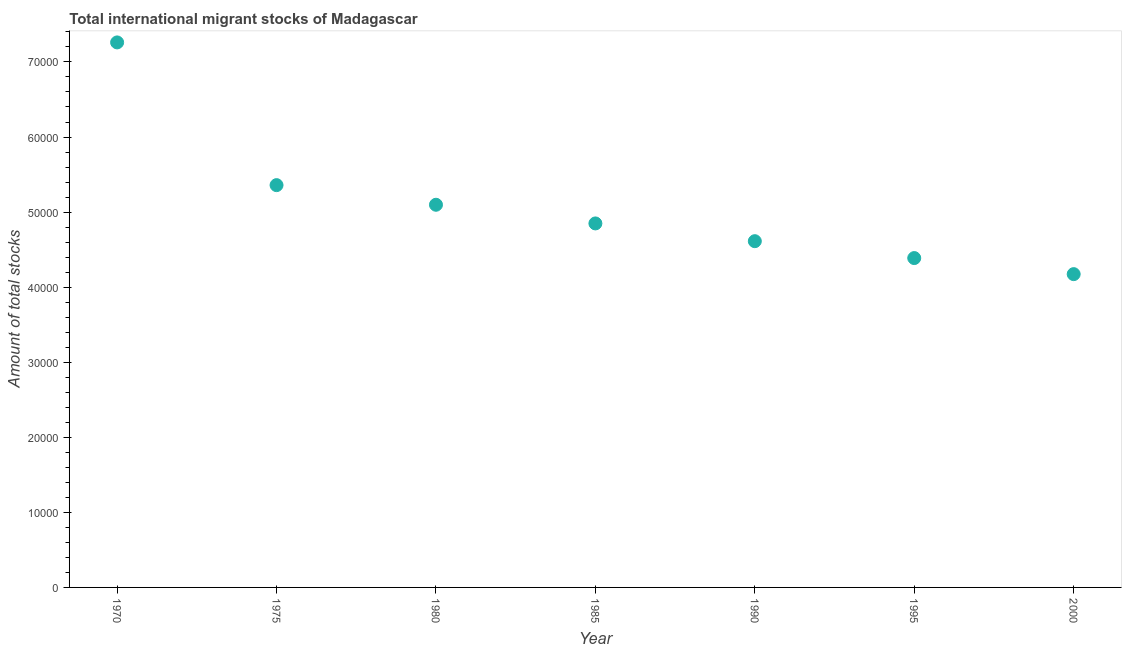What is the total number of international migrant stock in 1985?
Give a very brief answer. 4.85e+04. Across all years, what is the maximum total number of international migrant stock?
Your answer should be compact. 7.26e+04. Across all years, what is the minimum total number of international migrant stock?
Offer a terse response. 4.17e+04. What is the sum of the total number of international migrant stock?
Ensure brevity in your answer.  3.57e+05. What is the difference between the total number of international migrant stock in 1990 and 1995?
Offer a very short reply. 2250. What is the average total number of international migrant stock per year?
Provide a succinct answer. 5.11e+04. What is the median total number of international migrant stock?
Your answer should be compact. 4.85e+04. What is the ratio of the total number of international migrant stock in 1975 to that in 1995?
Keep it short and to the point. 1.22. Is the total number of international migrant stock in 1985 less than that in 2000?
Provide a short and direct response. No. Is the difference between the total number of international migrant stock in 1990 and 1995 greater than the difference between any two years?
Your response must be concise. No. What is the difference between the highest and the second highest total number of international migrant stock?
Give a very brief answer. 1.90e+04. Is the sum of the total number of international migrant stock in 1980 and 2000 greater than the maximum total number of international migrant stock across all years?
Your answer should be compact. Yes. What is the difference between the highest and the lowest total number of international migrant stock?
Offer a terse response. 3.09e+04. In how many years, is the total number of international migrant stock greater than the average total number of international migrant stock taken over all years?
Your response must be concise. 2. Does the total number of international migrant stock monotonically increase over the years?
Offer a very short reply. No. How many dotlines are there?
Give a very brief answer. 1. Does the graph contain grids?
Offer a terse response. No. What is the title of the graph?
Offer a very short reply. Total international migrant stocks of Madagascar. What is the label or title of the X-axis?
Make the answer very short. Year. What is the label or title of the Y-axis?
Your answer should be compact. Amount of total stocks. What is the Amount of total stocks in 1970?
Your response must be concise. 7.26e+04. What is the Amount of total stocks in 1975?
Provide a succinct answer. 5.36e+04. What is the Amount of total stocks in 1980?
Ensure brevity in your answer.  5.10e+04. What is the Amount of total stocks in 1985?
Give a very brief answer. 4.85e+04. What is the Amount of total stocks in 1990?
Offer a very short reply. 4.61e+04. What is the Amount of total stocks in 1995?
Your answer should be compact. 4.39e+04. What is the Amount of total stocks in 2000?
Offer a very short reply. 4.17e+04. What is the difference between the Amount of total stocks in 1970 and 1975?
Provide a short and direct response. 1.90e+04. What is the difference between the Amount of total stocks in 1970 and 1980?
Offer a very short reply. 2.16e+04. What is the difference between the Amount of total stocks in 1970 and 1985?
Your response must be concise. 2.41e+04. What is the difference between the Amount of total stocks in 1970 and 1990?
Your response must be concise. 2.65e+04. What is the difference between the Amount of total stocks in 1970 and 1995?
Provide a short and direct response. 2.87e+04. What is the difference between the Amount of total stocks in 1970 and 2000?
Your answer should be very brief. 3.09e+04. What is the difference between the Amount of total stocks in 1975 and 1980?
Offer a terse response. 2614. What is the difference between the Amount of total stocks in 1975 and 1985?
Your response must be concise. 5101. What is the difference between the Amount of total stocks in 1975 and 1990?
Make the answer very short. 7466. What is the difference between the Amount of total stocks in 1975 and 1995?
Keep it short and to the point. 9716. What is the difference between the Amount of total stocks in 1975 and 2000?
Offer a very short reply. 1.19e+04. What is the difference between the Amount of total stocks in 1980 and 1985?
Ensure brevity in your answer.  2487. What is the difference between the Amount of total stocks in 1980 and 1990?
Your response must be concise. 4852. What is the difference between the Amount of total stocks in 1980 and 1995?
Provide a succinct answer. 7102. What is the difference between the Amount of total stocks in 1980 and 2000?
Keep it short and to the point. 9242. What is the difference between the Amount of total stocks in 1985 and 1990?
Offer a very short reply. 2365. What is the difference between the Amount of total stocks in 1985 and 1995?
Give a very brief answer. 4615. What is the difference between the Amount of total stocks in 1985 and 2000?
Your answer should be very brief. 6755. What is the difference between the Amount of total stocks in 1990 and 1995?
Provide a short and direct response. 2250. What is the difference between the Amount of total stocks in 1990 and 2000?
Your response must be concise. 4390. What is the difference between the Amount of total stocks in 1995 and 2000?
Your answer should be compact. 2140. What is the ratio of the Amount of total stocks in 1970 to that in 1975?
Your answer should be very brief. 1.35. What is the ratio of the Amount of total stocks in 1970 to that in 1980?
Ensure brevity in your answer.  1.42. What is the ratio of the Amount of total stocks in 1970 to that in 1985?
Give a very brief answer. 1.5. What is the ratio of the Amount of total stocks in 1970 to that in 1990?
Ensure brevity in your answer.  1.57. What is the ratio of the Amount of total stocks in 1970 to that in 1995?
Provide a short and direct response. 1.66. What is the ratio of the Amount of total stocks in 1970 to that in 2000?
Your answer should be compact. 1.74. What is the ratio of the Amount of total stocks in 1975 to that in 1980?
Provide a succinct answer. 1.05. What is the ratio of the Amount of total stocks in 1975 to that in 1985?
Offer a very short reply. 1.1. What is the ratio of the Amount of total stocks in 1975 to that in 1990?
Offer a terse response. 1.16. What is the ratio of the Amount of total stocks in 1975 to that in 1995?
Your response must be concise. 1.22. What is the ratio of the Amount of total stocks in 1975 to that in 2000?
Provide a short and direct response. 1.28. What is the ratio of the Amount of total stocks in 1980 to that in 1985?
Keep it short and to the point. 1.05. What is the ratio of the Amount of total stocks in 1980 to that in 1990?
Provide a short and direct response. 1.1. What is the ratio of the Amount of total stocks in 1980 to that in 1995?
Your response must be concise. 1.16. What is the ratio of the Amount of total stocks in 1980 to that in 2000?
Offer a terse response. 1.22. What is the ratio of the Amount of total stocks in 1985 to that in 1990?
Your answer should be very brief. 1.05. What is the ratio of the Amount of total stocks in 1985 to that in 1995?
Your response must be concise. 1.1. What is the ratio of the Amount of total stocks in 1985 to that in 2000?
Provide a succinct answer. 1.16. What is the ratio of the Amount of total stocks in 1990 to that in 1995?
Your answer should be compact. 1.05. What is the ratio of the Amount of total stocks in 1990 to that in 2000?
Offer a very short reply. 1.1. What is the ratio of the Amount of total stocks in 1995 to that in 2000?
Your answer should be very brief. 1.05. 